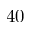<formula> <loc_0><loc_0><loc_500><loc_500>4 0</formula> 